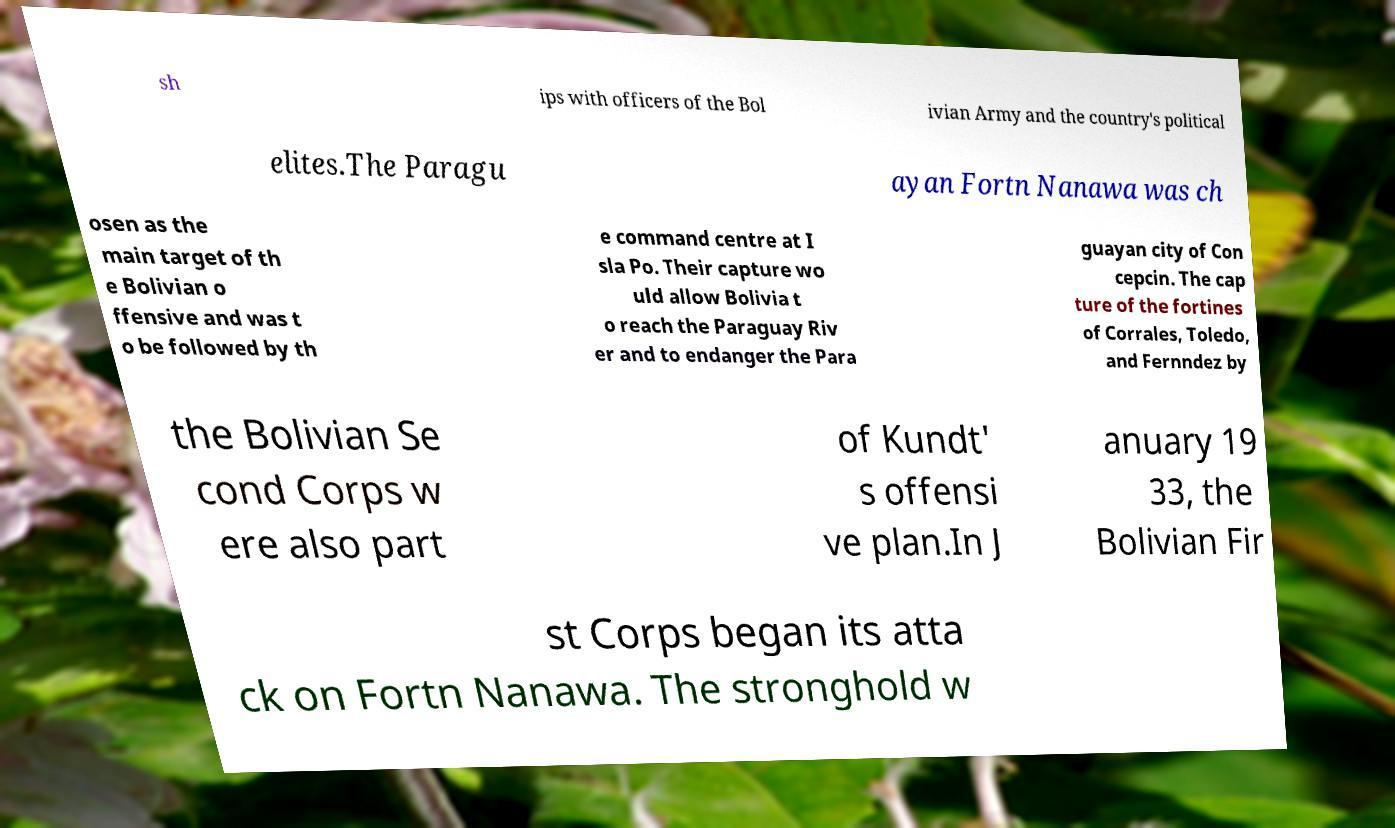There's text embedded in this image that I need extracted. Can you transcribe it verbatim? sh ips with officers of the Bol ivian Army and the country's political elites.The Paragu ayan Fortn Nanawa was ch osen as the main target of th e Bolivian o ffensive and was t o be followed by th e command centre at I sla Po. Their capture wo uld allow Bolivia t o reach the Paraguay Riv er and to endanger the Para guayan city of Con cepcin. The cap ture of the fortines of Corrales, Toledo, and Fernndez by the Bolivian Se cond Corps w ere also part of Kundt' s offensi ve plan.In J anuary 19 33, the Bolivian Fir st Corps began its atta ck on Fortn Nanawa. The stronghold w 